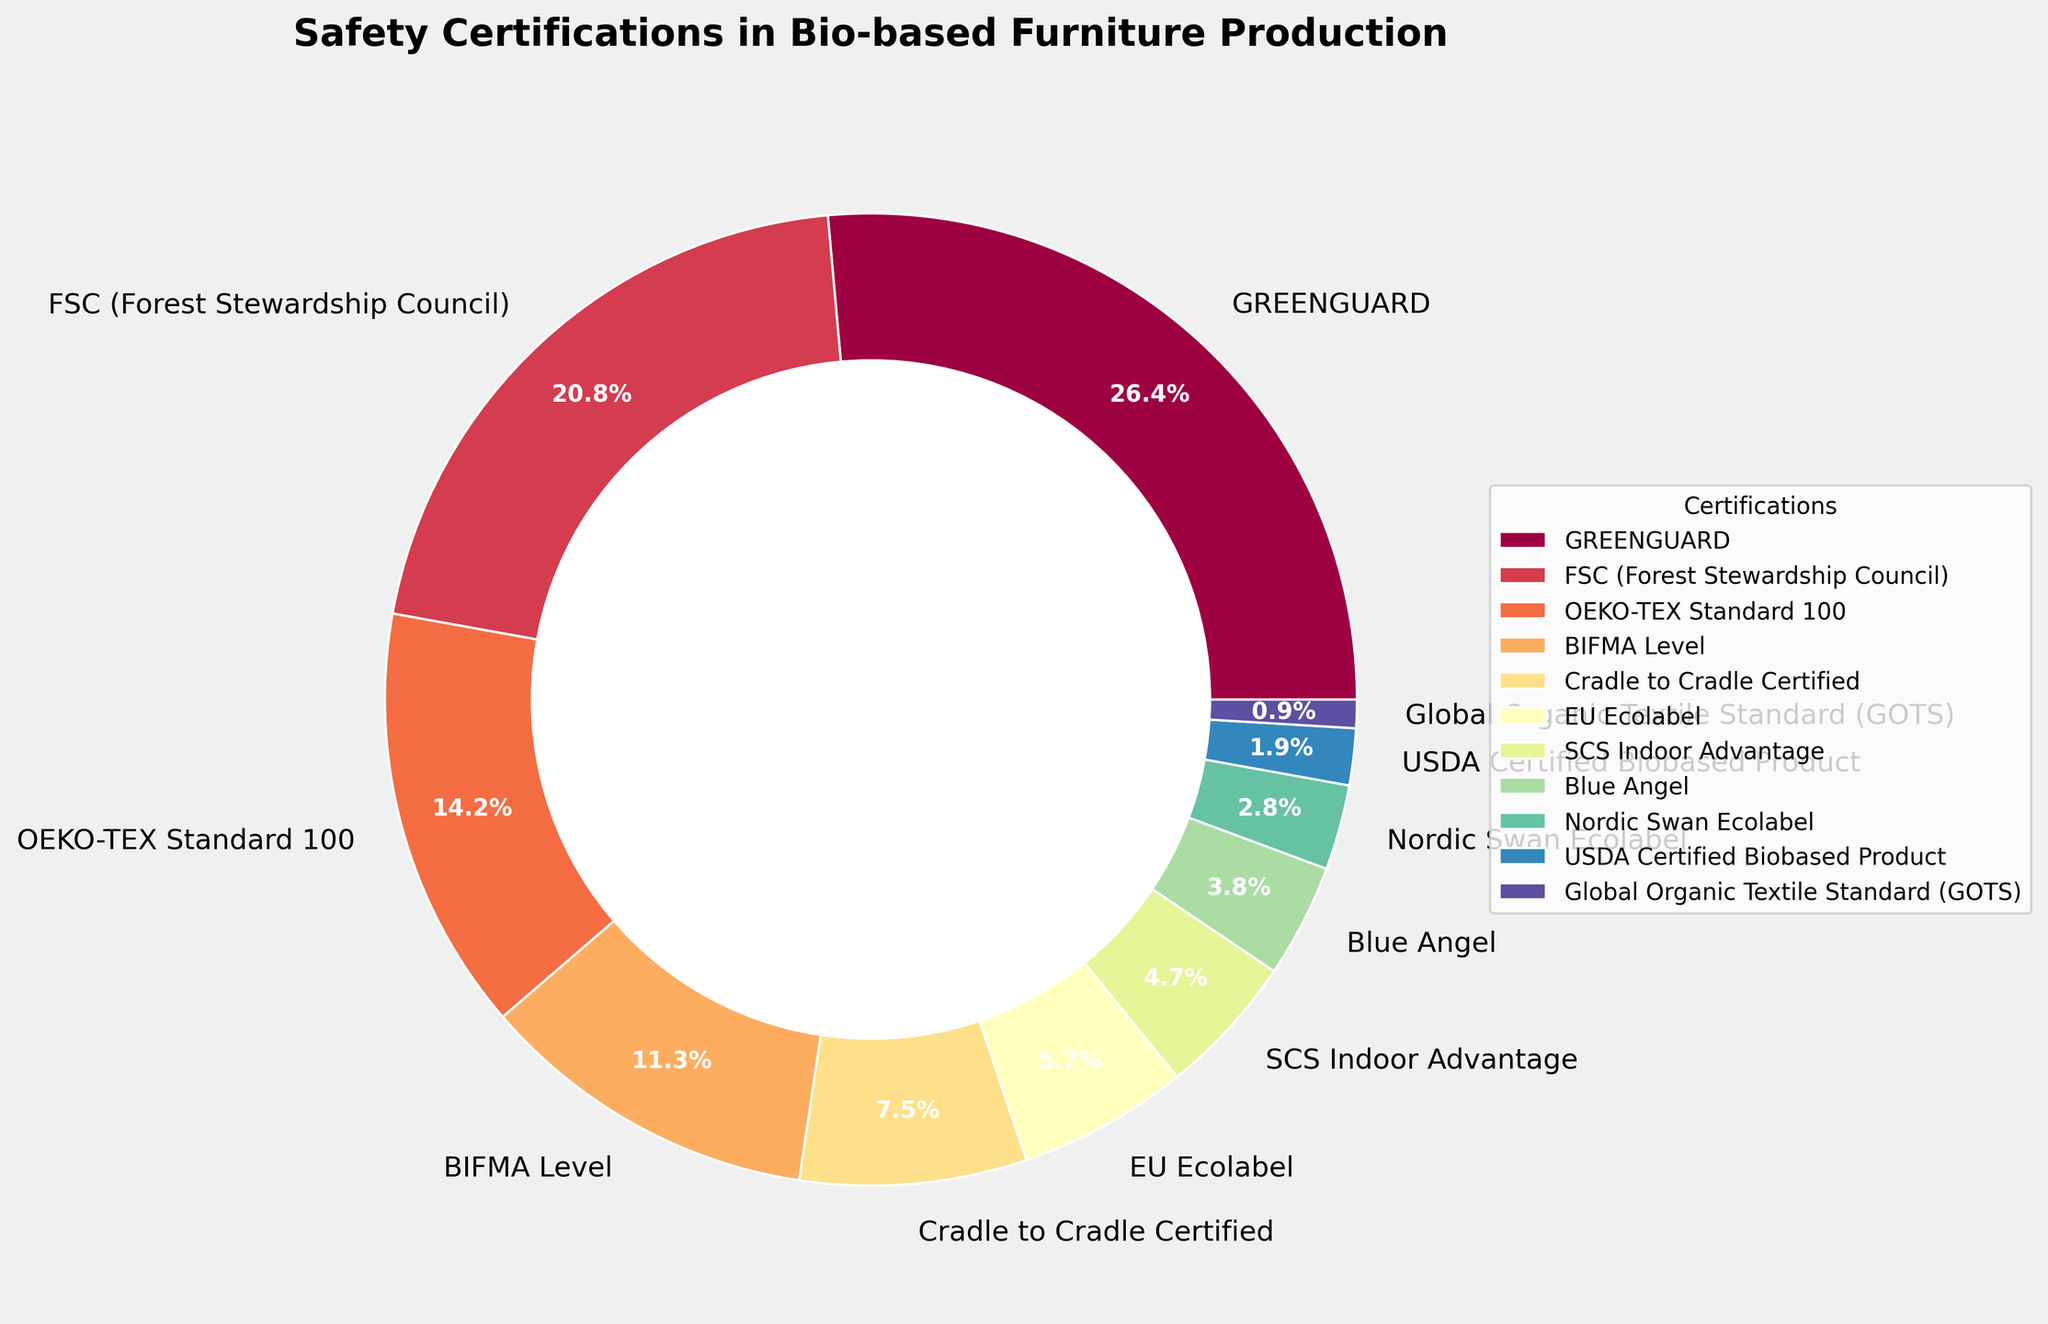Which certification is represented by the largest slice in the pie chart? The pie chart shows that the GREENGUARD certification segment takes up the most space compared to the other slices.
Answer: GREENGUARD What is the percentage difference between FSC and OEKO-TEX Standard 100 certifications? The FSC certification is 22% and the OEKO-TEX Standard 100 certification is 15%. The difference is calculated as 22% - 15% = 7%.
Answer: 7% Which certifications together make up more than half of the total percentage? The sum of the percentages for GREENGUARD, FSC, and OEKO-TEX Standard 100 certifications is 28% + 22% + 15% = 65%, which is more than half.
Answer: GREENGUARD, FSC, OEKO-TEX Standard 100 Compare the size of the slices for BIFMA Level and Cradle to Cradle Certified. Which one is larger and by how much? The BIFMA Level slice is 12% and the Cradle to Cradle Certified slice is 8%. The difference is 12% - 8% = 4%.
Answer: BIFMA Level, 4% Which certifications have a slice size smaller than 5%? The pie chart shows that SCS Indoor Advantage, Blue Angel, Nordic Swan Ecolabel, USDA Certified Biobased Product, and Global Organic Textile Standard (GOTS) all have slice sizes smaller than 5%.
Answer: SCS Indoor Advantage, Blue Angel, Nordic Swan Ecolabel, USDA Certified Biobased Product, GOTS How much larger is the percentage of GREENGUARD compared to the EU Ecolabel certification? The GREENGUARD certification holds 28% and the EU Ecolabel certification holds 6%. The difference is calculated as 28% - 6% = 22%.
Answer: 22% What is the combined percentage of the smallest three certifications? The percentages for Nordic Swan Ecolabel, USDA Certified Biobased Product, and Global Organic Textile Standard (GOTS) are 3%, 2%, and 1%, respectively. Their combined percentage is 3% + 2% + 1% = 6%.
Answer: 6% What percentage of the chart is taken up by the certifications represented in yellow and purple colors? Based on the color scheme (assuming GREENGUARD in yellow and SCS Indoor Advantage in purple, as examples), GREENGUARD is 28% and SCS Indoor Advantage is 5%. Combining these gives 28% + 5% = 33%.
Answer: 33% 